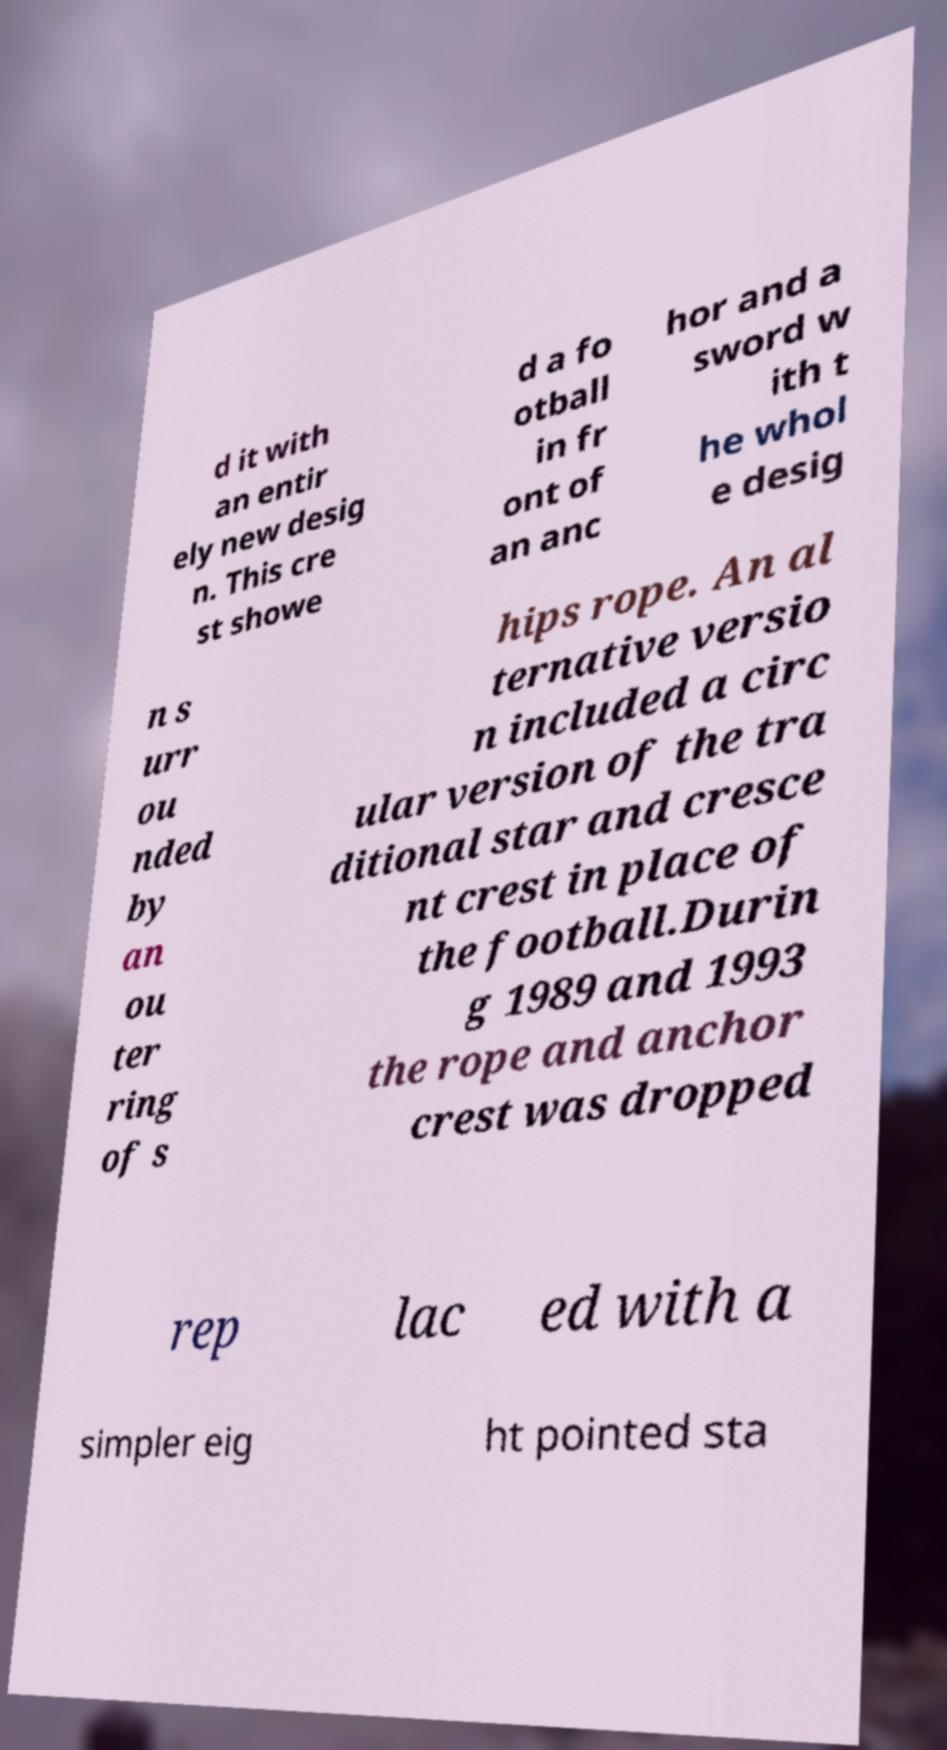There's text embedded in this image that I need extracted. Can you transcribe it verbatim? d it with an entir ely new desig n. This cre st showe d a fo otball in fr ont of an anc hor and a sword w ith t he whol e desig n s urr ou nded by an ou ter ring of s hips rope. An al ternative versio n included a circ ular version of the tra ditional star and cresce nt crest in place of the football.Durin g 1989 and 1993 the rope and anchor crest was dropped rep lac ed with a simpler eig ht pointed sta 